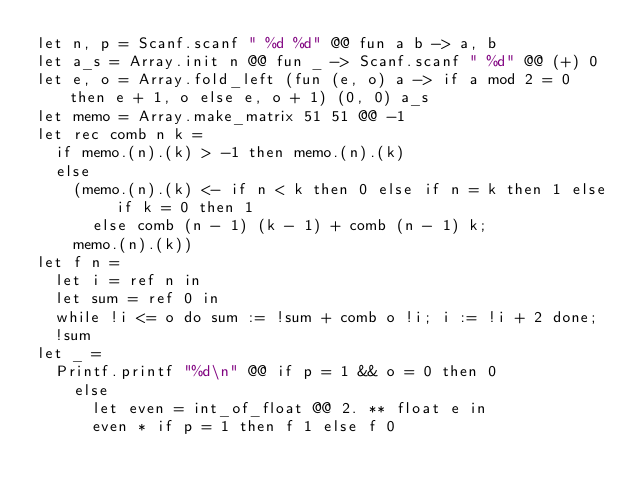<code> <loc_0><loc_0><loc_500><loc_500><_OCaml_>let n, p = Scanf.scanf " %d %d" @@ fun a b -> a, b
let a_s = Array.init n @@ fun _ -> Scanf.scanf " %d" @@ (+) 0
let e, o = Array.fold_left (fun (e, o) a -> if a mod 2 = 0 then e + 1, o else e, o + 1) (0, 0) a_s
let memo = Array.make_matrix 51 51 @@ -1
let rec comb n k =
  if memo.(n).(k) > -1 then memo.(n).(k)
  else
    (memo.(n).(k) <- if n < k then 0 else if n = k then 1 else if k = 0 then 1
      else comb (n - 1) (k - 1) + comb (n - 1) k;
    memo.(n).(k))
let f n =
  let i = ref n in
  let sum = ref 0 in
  while !i <= o do sum := !sum + comb o !i; i := !i + 2 done;
  !sum
let _ =
  Printf.printf "%d\n" @@ if p = 1 && o = 0 then 0
    else
      let even = int_of_float @@ 2. ** float e in
      even * if p = 1 then f 1 else f 0</code> 